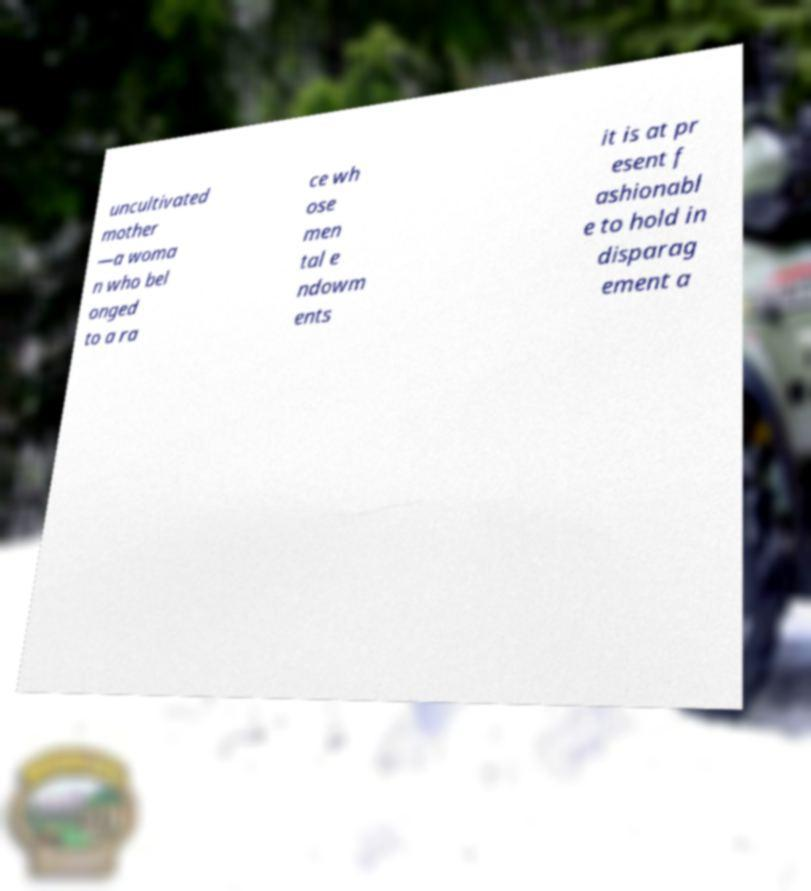Please identify and transcribe the text found in this image. uncultivated mother —a woma n who bel onged to a ra ce wh ose men tal e ndowm ents it is at pr esent f ashionabl e to hold in disparag ement a 